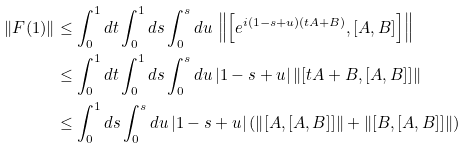Convert formula to latex. <formula><loc_0><loc_0><loc_500><loc_500>\| F ( 1 ) \| & \leq \int _ { 0 } ^ { 1 } d t \int _ { 0 } ^ { 1 } d s \int _ { 0 } ^ { s } d u \, \left \| \left [ e ^ { i ( 1 - s + u ) ( t A + B ) } , [ A , B ] \right ] \right \| \\ & \leq \int _ { 0 } ^ { 1 } d t \int _ { 0 } ^ { 1 } d s \int _ { 0 } ^ { s } d u \, | 1 - s + u | \left \| [ t A + B , [ A , B ] ] \right \| \\ & \leq \int _ { 0 } ^ { 1 } d s \int _ { 0 } ^ { s } d u \, | 1 - s + u | \left ( \left \| [ A , [ A , B ] ] \right \| + \left \| [ B , [ A , B ] ] \right \| \right )</formula> 